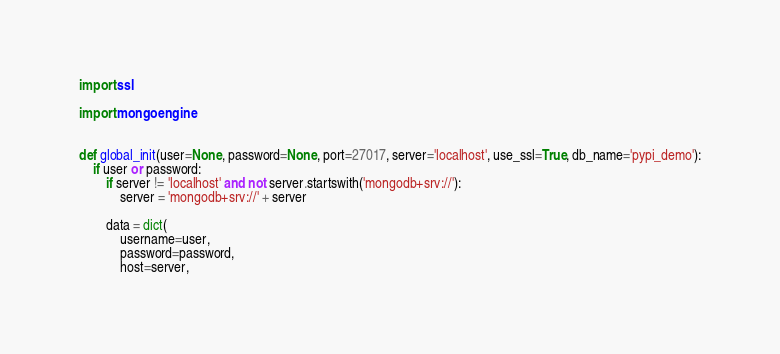Convert code to text. <code><loc_0><loc_0><loc_500><loc_500><_Python_>import ssl

import mongoengine


def global_init(user=None, password=None, port=27017, server='localhost', use_ssl=True, db_name='pypi_demo'):
    if user or password:
        if server != 'localhost' and not server.startswith('mongodb+srv://'):
            server = 'mongodb+srv://' + server

        data = dict(
            username=user,
            password=password,
            host=server,</code> 